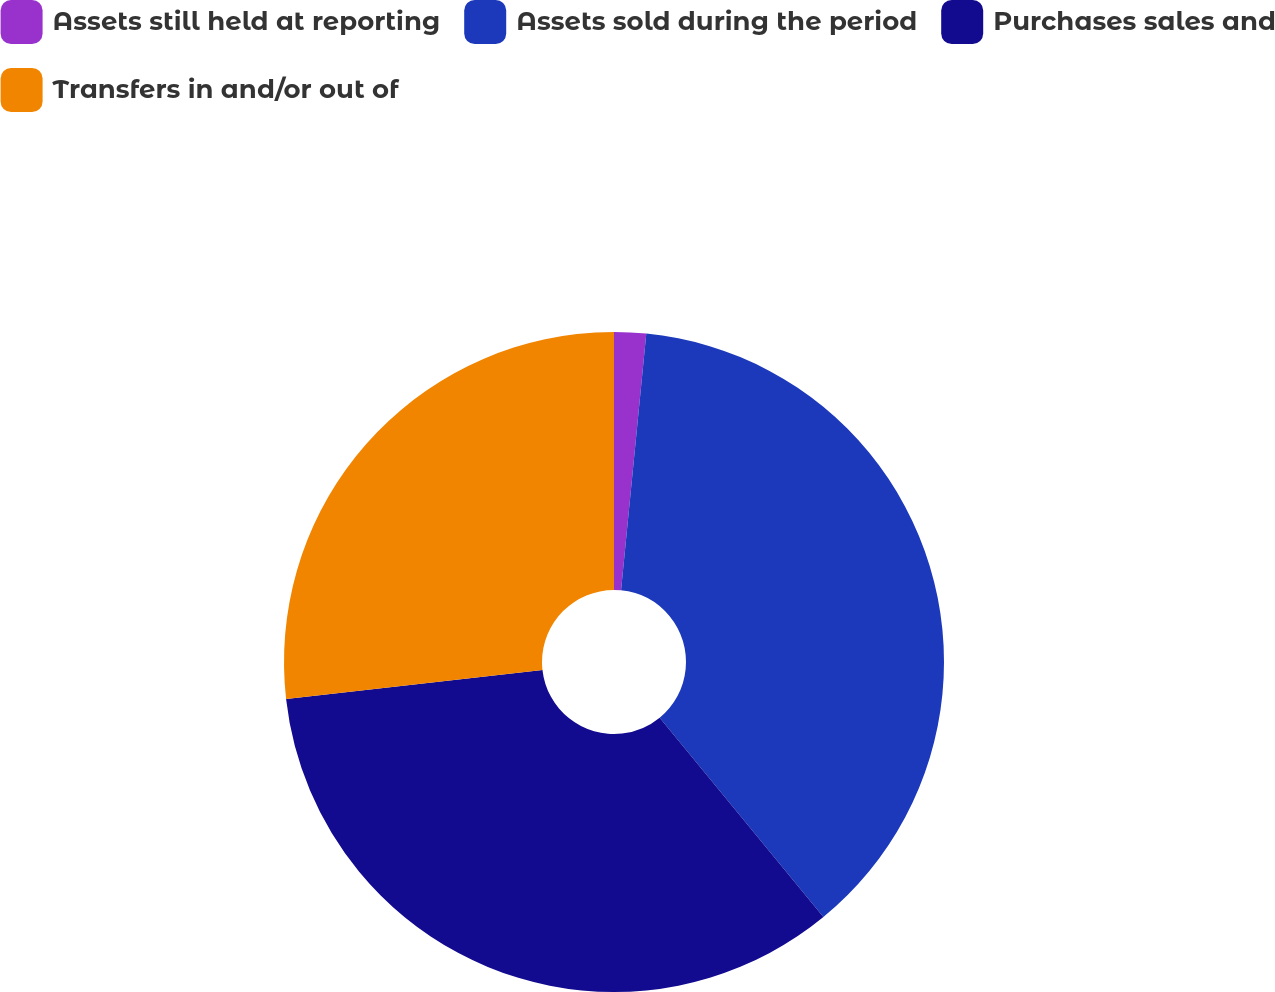Convert chart to OTSL. <chart><loc_0><loc_0><loc_500><loc_500><pie_chart><fcel>Assets still held at reporting<fcel>Assets sold during the period<fcel>Purchases sales and<fcel>Transfers in and/or out of<nl><fcel>1.56%<fcel>37.5%<fcel>34.15%<fcel>26.79%<nl></chart> 